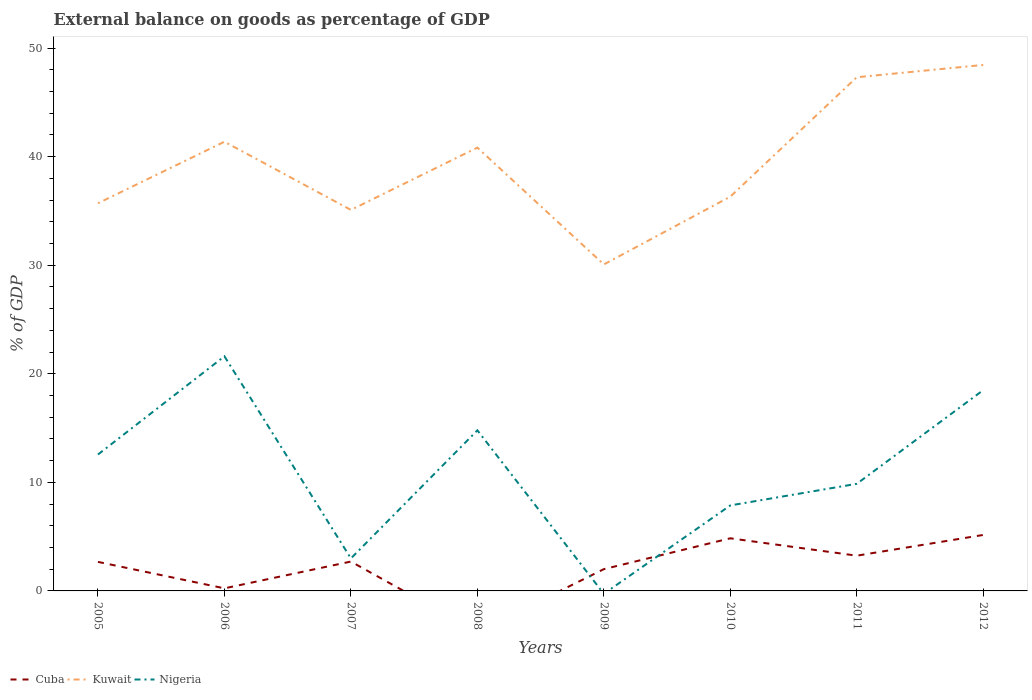How many different coloured lines are there?
Your response must be concise. 3. Is the number of lines equal to the number of legend labels?
Make the answer very short. No. What is the total external balance on goods as percentage of GDP in Kuwait in the graph?
Offer a terse response. -6.48. What is the difference between the highest and the second highest external balance on goods as percentage of GDP in Cuba?
Give a very brief answer. 5.16. Is the external balance on goods as percentage of GDP in Kuwait strictly greater than the external balance on goods as percentage of GDP in Nigeria over the years?
Ensure brevity in your answer.  No. How many years are there in the graph?
Give a very brief answer. 8. Are the values on the major ticks of Y-axis written in scientific E-notation?
Offer a very short reply. No. Where does the legend appear in the graph?
Keep it short and to the point. Bottom left. How are the legend labels stacked?
Make the answer very short. Horizontal. What is the title of the graph?
Provide a succinct answer. External balance on goods as percentage of GDP. What is the label or title of the X-axis?
Ensure brevity in your answer.  Years. What is the label or title of the Y-axis?
Your answer should be compact. % of GDP. What is the % of GDP in Cuba in 2005?
Provide a short and direct response. 2.67. What is the % of GDP in Kuwait in 2005?
Ensure brevity in your answer.  35.71. What is the % of GDP in Nigeria in 2005?
Offer a very short reply. 12.57. What is the % of GDP in Cuba in 2006?
Your answer should be very brief. 0.24. What is the % of GDP in Kuwait in 2006?
Give a very brief answer. 41.38. What is the % of GDP of Nigeria in 2006?
Make the answer very short. 21.61. What is the % of GDP in Cuba in 2007?
Provide a succinct answer. 2.71. What is the % of GDP in Kuwait in 2007?
Your answer should be compact. 35.1. What is the % of GDP of Nigeria in 2007?
Offer a terse response. 2.99. What is the % of GDP of Cuba in 2008?
Offer a terse response. 0. What is the % of GDP of Kuwait in 2008?
Your answer should be very brief. 40.84. What is the % of GDP in Nigeria in 2008?
Make the answer very short. 14.79. What is the % of GDP of Cuba in 2009?
Provide a short and direct response. 2.01. What is the % of GDP in Kuwait in 2009?
Give a very brief answer. 30.07. What is the % of GDP in Nigeria in 2009?
Offer a terse response. 0. What is the % of GDP in Cuba in 2010?
Your answer should be very brief. 4.85. What is the % of GDP in Kuwait in 2010?
Offer a very short reply. 36.32. What is the % of GDP in Nigeria in 2010?
Provide a succinct answer. 7.88. What is the % of GDP in Cuba in 2011?
Ensure brevity in your answer.  3.25. What is the % of GDP in Kuwait in 2011?
Provide a succinct answer. 47.32. What is the % of GDP of Nigeria in 2011?
Give a very brief answer. 9.87. What is the % of GDP in Cuba in 2012?
Ensure brevity in your answer.  5.16. What is the % of GDP of Kuwait in 2012?
Make the answer very short. 48.45. What is the % of GDP of Nigeria in 2012?
Make the answer very short. 18.5. Across all years, what is the maximum % of GDP in Cuba?
Keep it short and to the point. 5.16. Across all years, what is the maximum % of GDP in Kuwait?
Provide a short and direct response. 48.45. Across all years, what is the maximum % of GDP in Nigeria?
Offer a very short reply. 21.61. Across all years, what is the minimum % of GDP of Cuba?
Offer a terse response. 0. Across all years, what is the minimum % of GDP of Kuwait?
Make the answer very short. 30.07. What is the total % of GDP in Cuba in the graph?
Your response must be concise. 20.87. What is the total % of GDP in Kuwait in the graph?
Your response must be concise. 315.18. What is the total % of GDP of Nigeria in the graph?
Provide a short and direct response. 88.21. What is the difference between the % of GDP in Cuba in 2005 and that in 2006?
Keep it short and to the point. 2.44. What is the difference between the % of GDP in Kuwait in 2005 and that in 2006?
Your answer should be compact. -5.67. What is the difference between the % of GDP in Nigeria in 2005 and that in 2006?
Ensure brevity in your answer.  -9.05. What is the difference between the % of GDP in Cuba in 2005 and that in 2007?
Your answer should be very brief. -0.03. What is the difference between the % of GDP of Kuwait in 2005 and that in 2007?
Give a very brief answer. 0.61. What is the difference between the % of GDP in Nigeria in 2005 and that in 2007?
Make the answer very short. 9.57. What is the difference between the % of GDP in Kuwait in 2005 and that in 2008?
Your response must be concise. -5.13. What is the difference between the % of GDP of Nigeria in 2005 and that in 2008?
Your response must be concise. -2.23. What is the difference between the % of GDP of Cuba in 2005 and that in 2009?
Offer a very short reply. 0.67. What is the difference between the % of GDP of Kuwait in 2005 and that in 2009?
Make the answer very short. 5.64. What is the difference between the % of GDP of Cuba in 2005 and that in 2010?
Your response must be concise. -2.17. What is the difference between the % of GDP of Kuwait in 2005 and that in 2010?
Offer a terse response. -0.61. What is the difference between the % of GDP of Nigeria in 2005 and that in 2010?
Ensure brevity in your answer.  4.69. What is the difference between the % of GDP in Cuba in 2005 and that in 2011?
Make the answer very short. -0.57. What is the difference between the % of GDP in Kuwait in 2005 and that in 2011?
Provide a short and direct response. -11.61. What is the difference between the % of GDP of Nigeria in 2005 and that in 2011?
Your answer should be very brief. 2.7. What is the difference between the % of GDP in Cuba in 2005 and that in 2012?
Your answer should be compact. -2.48. What is the difference between the % of GDP in Kuwait in 2005 and that in 2012?
Offer a terse response. -12.74. What is the difference between the % of GDP in Nigeria in 2005 and that in 2012?
Offer a very short reply. -5.93. What is the difference between the % of GDP in Cuba in 2006 and that in 2007?
Offer a terse response. -2.47. What is the difference between the % of GDP in Kuwait in 2006 and that in 2007?
Make the answer very short. 6.28. What is the difference between the % of GDP in Nigeria in 2006 and that in 2007?
Your answer should be very brief. 18.62. What is the difference between the % of GDP in Kuwait in 2006 and that in 2008?
Provide a succinct answer. 0.54. What is the difference between the % of GDP in Nigeria in 2006 and that in 2008?
Offer a terse response. 6.82. What is the difference between the % of GDP of Cuba in 2006 and that in 2009?
Your response must be concise. -1.77. What is the difference between the % of GDP of Kuwait in 2006 and that in 2009?
Your response must be concise. 11.3. What is the difference between the % of GDP of Cuba in 2006 and that in 2010?
Make the answer very short. -4.61. What is the difference between the % of GDP of Kuwait in 2006 and that in 2010?
Your response must be concise. 5.06. What is the difference between the % of GDP of Nigeria in 2006 and that in 2010?
Make the answer very short. 13.74. What is the difference between the % of GDP of Cuba in 2006 and that in 2011?
Your answer should be compact. -3.01. What is the difference between the % of GDP of Kuwait in 2006 and that in 2011?
Give a very brief answer. -5.94. What is the difference between the % of GDP in Nigeria in 2006 and that in 2011?
Offer a very short reply. 11.75. What is the difference between the % of GDP of Cuba in 2006 and that in 2012?
Offer a terse response. -4.92. What is the difference between the % of GDP in Kuwait in 2006 and that in 2012?
Your answer should be very brief. -7.07. What is the difference between the % of GDP of Nigeria in 2006 and that in 2012?
Provide a short and direct response. 3.12. What is the difference between the % of GDP of Kuwait in 2007 and that in 2008?
Offer a very short reply. -5.74. What is the difference between the % of GDP in Nigeria in 2007 and that in 2008?
Offer a terse response. -11.8. What is the difference between the % of GDP in Cuba in 2007 and that in 2009?
Your answer should be compact. 0.7. What is the difference between the % of GDP in Kuwait in 2007 and that in 2009?
Give a very brief answer. 5.02. What is the difference between the % of GDP of Cuba in 2007 and that in 2010?
Offer a terse response. -2.14. What is the difference between the % of GDP in Kuwait in 2007 and that in 2010?
Give a very brief answer. -1.22. What is the difference between the % of GDP in Nigeria in 2007 and that in 2010?
Your answer should be compact. -4.88. What is the difference between the % of GDP in Cuba in 2007 and that in 2011?
Your answer should be very brief. -0.54. What is the difference between the % of GDP of Kuwait in 2007 and that in 2011?
Give a very brief answer. -12.22. What is the difference between the % of GDP in Nigeria in 2007 and that in 2011?
Give a very brief answer. -6.87. What is the difference between the % of GDP in Cuba in 2007 and that in 2012?
Provide a succinct answer. -2.45. What is the difference between the % of GDP in Kuwait in 2007 and that in 2012?
Offer a very short reply. -13.36. What is the difference between the % of GDP of Nigeria in 2007 and that in 2012?
Offer a terse response. -15.5. What is the difference between the % of GDP in Kuwait in 2008 and that in 2009?
Your answer should be compact. 10.76. What is the difference between the % of GDP of Kuwait in 2008 and that in 2010?
Give a very brief answer. 4.52. What is the difference between the % of GDP of Nigeria in 2008 and that in 2010?
Give a very brief answer. 6.92. What is the difference between the % of GDP of Kuwait in 2008 and that in 2011?
Offer a very short reply. -6.48. What is the difference between the % of GDP of Nigeria in 2008 and that in 2011?
Keep it short and to the point. 4.93. What is the difference between the % of GDP of Kuwait in 2008 and that in 2012?
Make the answer very short. -7.62. What is the difference between the % of GDP in Nigeria in 2008 and that in 2012?
Your answer should be compact. -3.7. What is the difference between the % of GDP of Cuba in 2009 and that in 2010?
Make the answer very short. -2.84. What is the difference between the % of GDP in Kuwait in 2009 and that in 2010?
Your answer should be compact. -6.24. What is the difference between the % of GDP in Cuba in 2009 and that in 2011?
Provide a succinct answer. -1.24. What is the difference between the % of GDP in Kuwait in 2009 and that in 2011?
Keep it short and to the point. -17.24. What is the difference between the % of GDP in Cuba in 2009 and that in 2012?
Ensure brevity in your answer.  -3.15. What is the difference between the % of GDP in Kuwait in 2009 and that in 2012?
Provide a succinct answer. -18.38. What is the difference between the % of GDP of Cuba in 2010 and that in 2011?
Your response must be concise. 1.6. What is the difference between the % of GDP of Kuwait in 2010 and that in 2011?
Offer a terse response. -11. What is the difference between the % of GDP of Nigeria in 2010 and that in 2011?
Provide a short and direct response. -1.99. What is the difference between the % of GDP in Cuba in 2010 and that in 2012?
Ensure brevity in your answer.  -0.31. What is the difference between the % of GDP of Kuwait in 2010 and that in 2012?
Your answer should be very brief. -12.13. What is the difference between the % of GDP of Nigeria in 2010 and that in 2012?
Provide a short and direct response. -10.62. What is the difference between the % of GDP of Cuba in 2011 and that in 2012?
Your answer should be compact. -1.91. What is the difference between the % of GDP of Kuwait in 2011 and that in 2012?
Provide a short and direct response. -1.13. What is the difference between the % of GDP in Nigeria in 2011 and that in 2012?
Offer a terse response. -8.63. What is the difference between the % of GDP in Cuba in 2005 and the % of GDP in Kuwait in 2006?
Your answer should be compact. -38.7. What is the difference between the % of GDP of Cuba in 2005 and the % of GDP of Nigeria in 2006?
Your answer should be compact. -18.94. What is the difference between the % of GDP of Kuwait in 2005 and the % of GDP of Nigeria in 2006?
Keep it short and to the point. 14.1. What is the difference between the % of GDP of Cuba in 2005 and the % of GDP of Kuwait in 2007?
Ensure brevity in your answer.  -32.42. What is the difference between the % of GDP of Cuba in 2005 and the % of GDP of Nigeria in 2007?
Keep it short and to the point. -0.32. What is the difference between the % of GDP of Kuwait in 2005 and the % of GDP of Nigeria in 2007?
Offer a very short reply. 32.72. What is the difference between the % of GDP in Cuba in 2005 and the % of GDP in Kuwait in 2008?
Your answer should be very brief. -38.16. What is the difference between the % of GDP of Cuba in 2005 and the % of GDP of Nigeria in 2008?
Your response must be concise. -12.12. What is the difference between the % of GDP of Kuwait in 2005 and the % of GDP of Nigeria in 2008?
Make the answer very short. 20.92. What is the difference between the % of GDP in Cuba in 2005 and the % of GDP in Kuwait in 2009?
Give a very brief answer. -27.4. What is the difference between the % of GDP in Cuba in 2005 and the % of GDP in Kuwait in 2010?
Your answer should be very brief. -33.65. What is the difference between the % of GDP of Cuba in 2005 and the % of GDP of Nigeria in 2010?
Keep it short and to the point. -5.2. What is the difference between the % of GDP of Kuwait in 2005 and the % of GDP of Nigeria in 2010?
Offer a terse response. 27.83. What is the difference between the % of GDP in Cuba in 2005 and the % of GDP in Kuwait in 2011?
Your response must be concise. -44.64. What is the difference between the % of GDP in Cuba in 2005 and the % of GDP in Nigeria in 2011?
Provide a succinct answer. -7.19. What is the difference between the % of GDP in Kuwait in 2005 and the % of GDP in Nigeria in 2011?
Your answer should be very brief. 25.84. What is the difference between the % of GDP of Cuba in 2005 and the % of GDP of Kuwait in 2012?
Give a very brief answer. -45.78. What is the difference between the % of GDP of Cuba in 2005 and the % of GDP of Nigeria in 2012?
Offer a very short reply. -15.82. What is the difference between the % of GDP of Kuwait in 2005 and the % of GDP of Nigeria in 2012?
Offer a terse response. 17.21. What is the difference between the % of GDP of Cuba in 2006 and the % of GDP of Kuwait in 2007?
Provide a succinct answer. -34.86. What is the difference between the % of GDP in Cuba in 2006 and the % of GDP in Nigeria in 2007?
Your answer should be very brief. -2.76. What is the difference between the % of GDP in Kuwait in 2006 and the % of GDP in Nigeria in 2007?
Provide a short and direct response. 38.38. What is the difference between the % of GDP of Cuba in 2006 and the % of GDP of Kuwait in 2008?
Provide a short and direct response. -40.6. What is the difference between the % of GDP of Cuba in 2006 and the % of GDP of Nigeria in 2008?
Make the answer very short. -14.55. What is the difference between the % of GDP of Kuwait in 2006 and the % of GDP of Nigeria in 2008?
Your response must be concise. 26.58. What is the difference between the % of GDP of Cuba in 2006 and the % of GDP of Kuwait in 2009?
Your answer should be compact. -29.84. What is the difference between the % of GDP in Cuba in 2006 and the % of GDP in Kuwait in 2010?
Offer a very short reply. -36.08. What is the difference between the % of GDP in Cuba in 2006 and the % of GDP in Nigeria in 2010?
Offer a very short reply. -7.64. What is the difference between the % of GDP in Kuwait in 2006 and the % of GDP in Nigeria in 2010?
Give a very brief answer. 33.5. What is the difference between the % of GDP of Cuba in 2006 and the % of GDP of Kuwait in 2011?
Give a very brief answer. -47.08. What is the difference between the % of GDP of Cuba in 2006 and the % of GDP of Nigeria in 2011?
Provide a succinct answer. -9.63. What is the difference between the % of GDP of Kuwait in 2006 and the % of GDP of Nigeria in 2011?
Your response must be concise. 31.51. What is the difference between the % of GDP of Cuba in 2006 and the % of GDP of Kuwait in 2012?
Offer a very short reply. -48.21. What is the difference between the % of GDP of Cuba in 2006 and the % of GDP of Nigeria in 2012?
Your response must be concise. -18.26. What is the difference between the % of GDP in Kuwait in 2006 and the % of GDP in Nigeria in 2012?
Your response must be concise. 22.88. What is the difference between the % of GDP of Cuba in 2007 and the % of GDP of Kuwait in 2008?
Offer a terse response. -38.13. What is the difference between the % of GDP of Cuba in 2007 and the % of GDP of Nigeria in 2008?
Provide a short and direct response. -12.09. What is the difference between the % of GDP of Kuwait in 2007 and the % of GDP of Nigeria in 2008?
Make the answer very short. 20.3. What is the difference between the % of GDP in Cuba in 2007 and the % of GDP in Kuwait in 2009?
Ensure brevity in your answer.  -27.37. What is the difference between the % of GDP in Cuba in 2007 and the % of GDP in Kuwait in 2010?
Offer a terse response. -33.61. What is the difference between the % of GDP of Cuba in 2007 and the % of GDP of Nigeria in 2010?
Your answer should be compact. -5.17. What is the difference between the % of GDP of Kuwait in 2007 and the % of GDP of Nigeria in 2010?
Provide a short and direct response. 27.22. What is the difference between the % of GDP of Cuba in 2007 and the % of GDP of Kuwait in 2011?
Your answer should be compact. -44.61. What is the difference between the % of GDP in Cuba in 2007 and the % of GDP in Nigeria in 2011?
Offer a very short reply. -7.16. What is the difference between the % of GDP of Kuwait in 2007 and the % of GDP of Nigeria in 2011?
Keep it short and to the point. 25.23. What is the difference between the % of GDP of Cuba in 2007 and the % of GDP of Kuwait in 2012?
Ensure brevity in your answer.  -45.75. What is the difference between the % of GDP in Cuba in 2007 and the % of GDP in Nigeria in 2012?
Offer a very short reply. -15.79. What is the difference between the % of GDP of Kuwait in 2007 and the % of GDP of Nigeria in 2012?
Provide a succinct answer. 16.6. What is the difference between the % of GDP of Kuwait in 2008 and the % of GDP of Nigeria in 2010?
Provide a succinct answer. 32.96. What is the difference between the % of GDP in Kuwait in 2008 and the % of GDP in Nigeria in 2011?
Offer a very short reply. 30.97. What is the difference between the % of GDP in Kuwait in 2008 and the % of GDP in Nigeria in 2012?
Your response must be concise. 22.34. What is the difference between the % of GDP of Cuba in 2009 and the % of GDP of Kuwait in 2010?
Provide a short and direct response. -34.31. What is the difference between the % of GDP in Cuba in 2009 and the % of GDP in Nigeria in 2010?
Your answer should be compact. -5.87. What is the difference between the % of GDP in Kuwait in 2009 and the % of GDP in Nigeria in 2010?
Your answer should be very brief. 22.2. What is the difference between the % of GDP of Cuba in 2009 and the % of GDP of Kuwait in 2011?
Provide a short and direct response. -45.31. What is the difference between the % of GDP in Cuba in 2009 and the % of GDP in Nigeria in 2011?
Provide a succinct answer. -7.86. What is the difference between the % of GDP in Kuwait in 2009 and the % of GDP in Nigeria in 2011?
Provide a succinct answer. 20.21. What is the difference between the % of GDP of Cuba in 2009 and the % of GDP of Kuwait in 2012?
Give a very brief answer. -46.45. What is the difference between the % of GDP in Cuba in 2009 and the % of GDP in Nigeria in 2012?
Provide a succinct answer. -16.49. What is the difference between the % of GDP of Kuwait in 2009 and the % of GDP of Nigeria in 2012?
Offer a very short reply. 11.58. What is the difference between the % of GDP in Cuba in 2010 and the % of GDP in Kuwait in 2011?
Offer a very short reply. -42.47. What is the difference between the % of GDP in Cuba in 2010 and the % of GDP in Nigeria in 2011?
Offer a very short reply. -5.02. What is the difference between the % of GDP in Kuwait in 2010 and the % of GDP in Nigeria in 2011?
Make the answer very short. 26.45. What is the difference between the % of GDP in Cuba in 2010 and the % of GDP in Kuwait in 2012?
Give a very brief answer. -43.6. What is the difference between the % of GDP of Cuba in 2010 and the % of GDP of Nigeria in 2012?
Offer a terse response. -13.65. What is the difference between the % of GDP in Kuwait in 2010 and the % of GDP in Nigeria in 2012?
Make the answer very short. 17.82. What is the difference between the % of GDP of Cuba in 2011 and the % of GDP of Kuwait in 2012?
Your answer should be compact. -45.21. What is the difference between the % of GDP in Cuba in 2011 and the % of GDP in Nigeria in 2012?
Your response must be concise. -15.25. What is the difference between the % of GDP in Kuwait in 2011 and the % of GDP in Nigeria in 2012?
Offer a terse response. 28.82. What is the average % of GDP in Cuba per year?
Your answer should be compact. 2.61. What is the average % of GDP of Kuwait per year?
Offer a terse response. 39.4. What is the average % of GDP of Nigeria per year?
Ensure brevity in your answer.  11.03. In the year 2005, what is the difference between the % of GDP in Cuba and % of GDP in Kuwait?
Make the answer very short. -33.04. In the year 2005, what is the difference between the % of GDP in Cuba and % of GDP in Nigeria?
Provide a succinct answer. -9.89. In the year 2005, what is the difference between the % of GDP in Kuwait and % of GDP in Nigeria?
Your response must be concise. 23.14. In the year 2006, what is the difference between the % of GDP of Cuba and % of GDP of Kuwait?
Offer a very short reply. -41.14. In the year 2006, what is the difference between the % of GDP of Cuba and % of GDP of Nigeria?
Provide a short and direct response. -21.38. In the year 2006, what is the difference between the % of GDP of Kuwait and % of GDP of Nigeria?
Offer a very short reply. 19.76. In the year 2007, what is the difference between the % of GDP in Cuba and % of GDP in Kuwait?
Keep it short and to the point. -32.39. In the year 2007, what is the difference between the % of GDP in Cuba and % of GDP in Nigeria?
Your response must be concise. -0.29. In the year 2007, what is the difference between the % of GDP of Kuwait and % of GDP of Nigeria?
Offer a very short reply. 32.1. In the year 2008, what is the difference between the % of GDP of Kuwait and % of GDP of Nigeria?
Provide a short and direct response. 26.04. In the year 2009, what is the difference between the % of GDP in Cuba and % of GDP in Kuwait?
Give a very brief answer. -28.07. In the year 2010, what is the difference between the % of GDP in Cuba and % of GDP in Kuwait?
Provide a short and direct response. -31.47. In the year 2010, what is the difference between the % of GDP of Cuba and % of GDP of Nigeria?
Give a very brief answer. -3.03. In the year 2010, what is the difference between the % of GDP of Kuwait and % of GDP of Nigeria?
Your response must be concise. 28.44. In the year 2011, what is the difference between the % of GDP of Cuba and % of GDP of Kuwait?
Make the answer very short. -44.07. In the year 2011, what is the difference between the % of GDP of Cuba and % of GDP of Nigeria?
Your answer should be compact. -6.62. In the year 2011, what is the difference between the % of GDP in Kuwait and % of GDP in Nigeria?
Offer a terse response. 37.45. In the year 2012, what is the difference between the % of GDP in Cuba and % of GDP in Kuwait?
Your answer should be compact. -43.3. In the year 2012, what is the difference between the % of GDP in Cuba and % of GDP in Nigeria?
Your response must be concise. -13.34. In the year 2012, what is the difference between the % of GDP of Kuwait and % of GDP of Nigeria?
Your answer should be compact. 29.95. What is the ratio of the % of GDP of Cuba in 2005 to that in 2006?
Your answer should be compact. 11.22. What is the ratio of the % of GDP in Kuwait in 2005 to that in 2006?
Offer a very short reply. 0.86. What is the ratio of the % of GDP in Nigeria in 2005 to that in 2006?
Your response must be concise. 0.58. What is the ratio of the % of GDP of Kuwait in 2005 to that in 2007?
Provide a short and direct response. 1.02. What is the ratio of the % of GDP of Nigeria in 2005 to that in 2007?
Make the answer very short. 4.2. What is the ratio of the % of GDP in Kuwait in 2005 to that in 2008?
Keep it short and to the point. 0.87. What is the ratio of the % of GDP in Nigeria in 2005 to that in 2008?
Offer a terse response. 0.85. What is the ratio of the % of GDP in Cuba in 2005 to that in 2009?
Your answer should be very brief. 1.33. What is the ratio of the % of GDP of Kuwait in 2005 to that in 2009?
Your answer should be compact. 1.19. What is the ratio of the % of GDP of Cuba in 2005 to that in 2010?
Offer a very short reply. 0.55. What is the ratio of the % of GDP of Kuwait in 2005 to that in 2010?
Provide a succinct answer. 0.98. What is the ratio of the % of GDP of Nigeria in 2005 to that in 2010?
Give a very brief answer. 1.6. What is the ratio of the % of GDP of Cuba in 2005 to that in 2011?
Your response must be concise. 0.82. What is the ratio of the % of GDP of Kuwait in 2005 to that in 2011?
Keep it short and to the point. 0.75. What is the ratio of the % of GDP of Nigeria in 2005 to that in 2011?
Provide a succinct answer. 1.27. What is the ratio of the % of GDP of Cuba in 2005 to that in 2012?
Provide a succinct answer. 0.52. What is the ratio of the % of GDP of Kuwait in 2005 to that in 2012?
Your response must be concise. 0.74. What is the ratio of the % of GDP of Nigeria in 2005 to that in 2012?
Your response must be concise. 0.68. What is the ratio of the % of GDP in Cuba in 2006 to that in 2007?
Make the answer very short. 0.09. What is the ratio of the % of GDP in Kuwait in 2006 to that in 2007?
Offer a very short reply. 1.18. What is the ratio of the % of GDP of Nigeria in 2006 to that in 2007?
Make the answer very short. 7.22. What is the ratio of the % of GDP in Kuwait in 2006 to that in 2008?
Your response must be concise. 1.01. What is the ratio of the % of GDP of Nigeria in 2006 to that in 2008?
Keep it short and to the point. 1.46. What is the ratio of the % of GDP in Cuba in 2006 to that in 2009?
Offer a very short reply. 0.12. What is the ratio of the % of GDP of Kuwait in 2006 to that in 2009?
Offer a terse response. 1.38. What is the ratio of the % of GDP in Cuba in 2006 to that in 2010?
Offer a very short reply. 0.05. What is the ratio of the % of GDP in Kuwait in 2006 to that in 2010?
Offer a very short reply. 1.14. What is the ratio of the % of GDP of Nigeria in 2006 to that in 2010?
Offer a terse response. 2.74. What is the ratio of the % of GDP of Cuba in 2006 to that in 2011?
Your answer should be very brief. 0.07. What is the ratio of the % of GDP of Kuwait in 2006 to that in 2011?
Your answer should be compact. 0.87. What is the ratio of the % of GDP in Nigeria in 2006 to that in 2011?
Your response must be concise. 2.19. What is the ratio of the % of GDP of Cuba in 2006 to that in 2012?
Keep it short and to the point. 0.05. What is the ratio of the % of GDP of Kuwait in 2006 to that in 2012?
Make the answer very short. 0.85. What is the ratio of the % of GDP of Nigeria in 2006 to that in 2012?
Provide a succinct answer. 1.17. What is the ratio of the % of GDP of Kuwait in 2007 to that in 2008?
Offer a very short reply. 0.86. What is the ratio of the % of GDP of Nigeria in 2007 to that in 2008?
Give a very brief answer. 0.2. What is the ratio of the % of GDP of Cuba in 2007 to that in 2009?
Your answer should be compact. 1.35. What is the ratio of the % of GDP in Kuwait in 2007 to that in 2009?
Ensure brevity in your answer.  1.17. What is the ratio of the % of GDP of Cuba in 2007 to that in 2010?
Your response must be concise. 0.56. What is the ratio of the % of GDP in Kuwait in 2007 to that in 2010?
Your answer should be very brief. 0.97. What is the ratio of the % of GDP of Nigeria in 2007 to that in 2010?
Your answer should be very brief. 0.38. What is the ratio of the % of GDP of Cuba in 2007 to that in 2011?
Offer a terse response. 0.83. What is the ratio of the % of GDP in Kuwait in 2007 to that in 2011?
Ensure brevity in your answer.  0.74. What is the ratio of the % of GDP in Nigeria in 2007 to that in 2011?
Provide a succinct answer. 0.3. What is the ratio of the % of GDP in Cuba in 2007 to that in 2012?
Your answer should be compact. 0.52. What is the ratio of the % of GDP in Kuwait in 2007 to that in 2012?
Ensure brevity in your answer.  0.72. What is the ratio of the % of GDP of Nigeria in 2007 to that in 2012?
Ensure brevity in your answer.  0.16. What is the ratio of the % of GDP of Kuwait in 2008 to that in 2009?
Ensure brevity in your answer.  1.36. What is the ratio of the % of GDP in Kuwait in 2008 to that in 2010?
Offer a very short reply. 1.12. What is the ratio of the % of GDP of Nigeria in 2008 to that in 2010?
Make the answer very short. 1.88. What is the ratio of the % of GDP in Kuwait in 2008 to that in 2011?
Your response must be concise. 0.86. What is the ratio of the % of GDP in Nigeria in 2008 to that in 2011?
Give a very brief answer. 1.5. What is the ratio of the % of GDP of Kuwait in 2008 to that in 2012?
Make the answer very short. 0.84. What is the ratio of the % of GDP in Nigeria in 2008 to that in 2012?
Offer a terse response. 0.8. What is the ratio of the % of GDP in Cuba in 2009 to that in 2010?
Your response must be concise. 0.41. What is the ratio of the % of GDP in Kuwait in 2009 to that in 2010?
Provide a short and direct response. 0.83. What is the ratio of the % of GDP of Cuba in 2009 to that in 2011?
Offer a very short reply. 0.62. What is the ratio of the % of GDP of Kuwait in 2009 to that in 2011?
Your response must be concise. 0.64. What is the ratio of the % of GDP of Cuba in 2009 to that in 2012?
Keep it short and to the point. 0.39. What is the ratio of the % of GDP in Kuwait in 2009 to that in 2012?
Keep it short and to the point. 0.62. What is the ratio of the % of GDP in Cuba in 2010 to that in 2011?
Your response must be concise. 1.49. What is the ratio of the % of GDP of Kuwait in 2010 to that in 2011?
Offer a very short reply. 0.77. What is the ratio of the % of GDP in Nigeria in 2010 to that in 2011?
Your answer should be very brief. 0.8. What is the ratio of the % of GDP of Cuba in 2010 to that in 2012?
Your answer should be very brief. 0.94. What is the ratio of the % of GDP in Kuwait in 2010 to that in 2012?
Your answer should be compact. 0.75. What is the ratio of the % of GDP in Nigeria in 2010 to that in 2012?
Keep it short and to the point. 0.43. What is the ratio of the % of GDP of Cuba in 2011 to that in 2012?
Your answer should be very brief. 0.63. What is the ratio of the % of GDP in Kuwait in 2011 to that in 2012?
Give a very brief answer. 0.98. What is the ratio of the % of GDP in Nigeria in 2011 to that in 2012?
Offer a terse response. 0.53. What is the difference between the highest and the second highest % of GDP of Cuba?
Provide a short and direct response. 0.31. What is the difference between the highest and the second highest % of GDP of Kuwait?
Your answer should be very brief. 1.13. What is the difference between the highest and the second highest % of GDP in Nigeria?
Provide a succinct answer. 3.12. What is the difference between the highest and the lowest % of GDP of Cuba?
Your answer should be compact. 5.16. What is the difference between the highest and the lowest % of GDP in Kuwait?
Give a very brief answer. 18.38. What is the difference between the highest and the lowest % of GDP in Nigeria?
Ensure brevity in your answer.  21.61. 